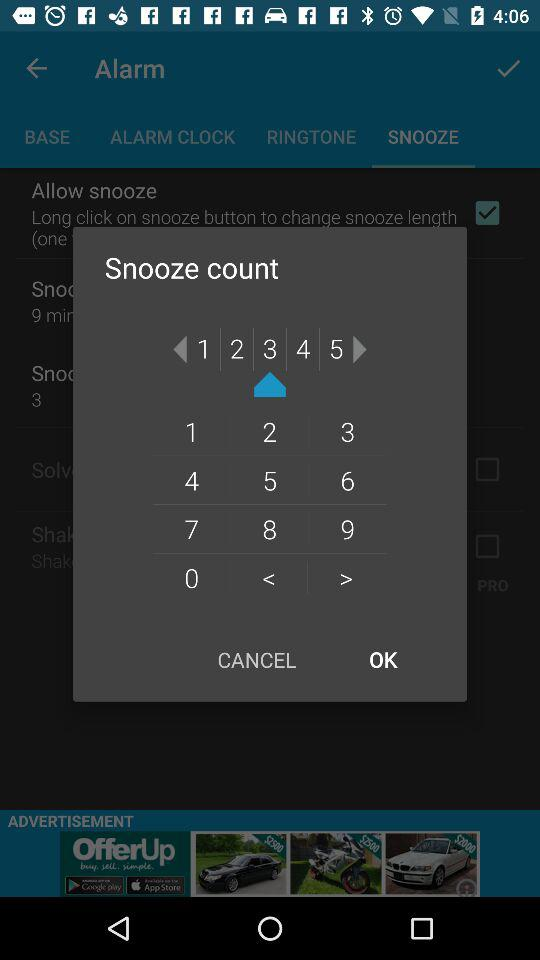Which tab of "Alarm" am I on? You are on the "SNOOZE" tab. 